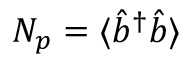Convert formula to latex. <formula><loc_0><loc_0><loc_500><loc_500>N _ { p } = \langle \hat { b } ^ { \dagger } \hat { b } \rangle</formula> 